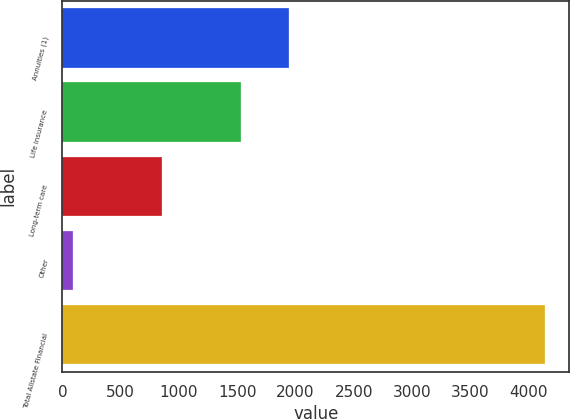<chart> <loc_0><loc_0><loc_500><loc_500><bar_chart><fcel>Annuities (1)<fcel>Life insurance<fcel>Long-term care<fcel>Other<fcel>Total Allstate Financial<nl><fcel>1940.3<fcel>1535<fcel>851<fcel>90<fcel>4143<nl></chart> 